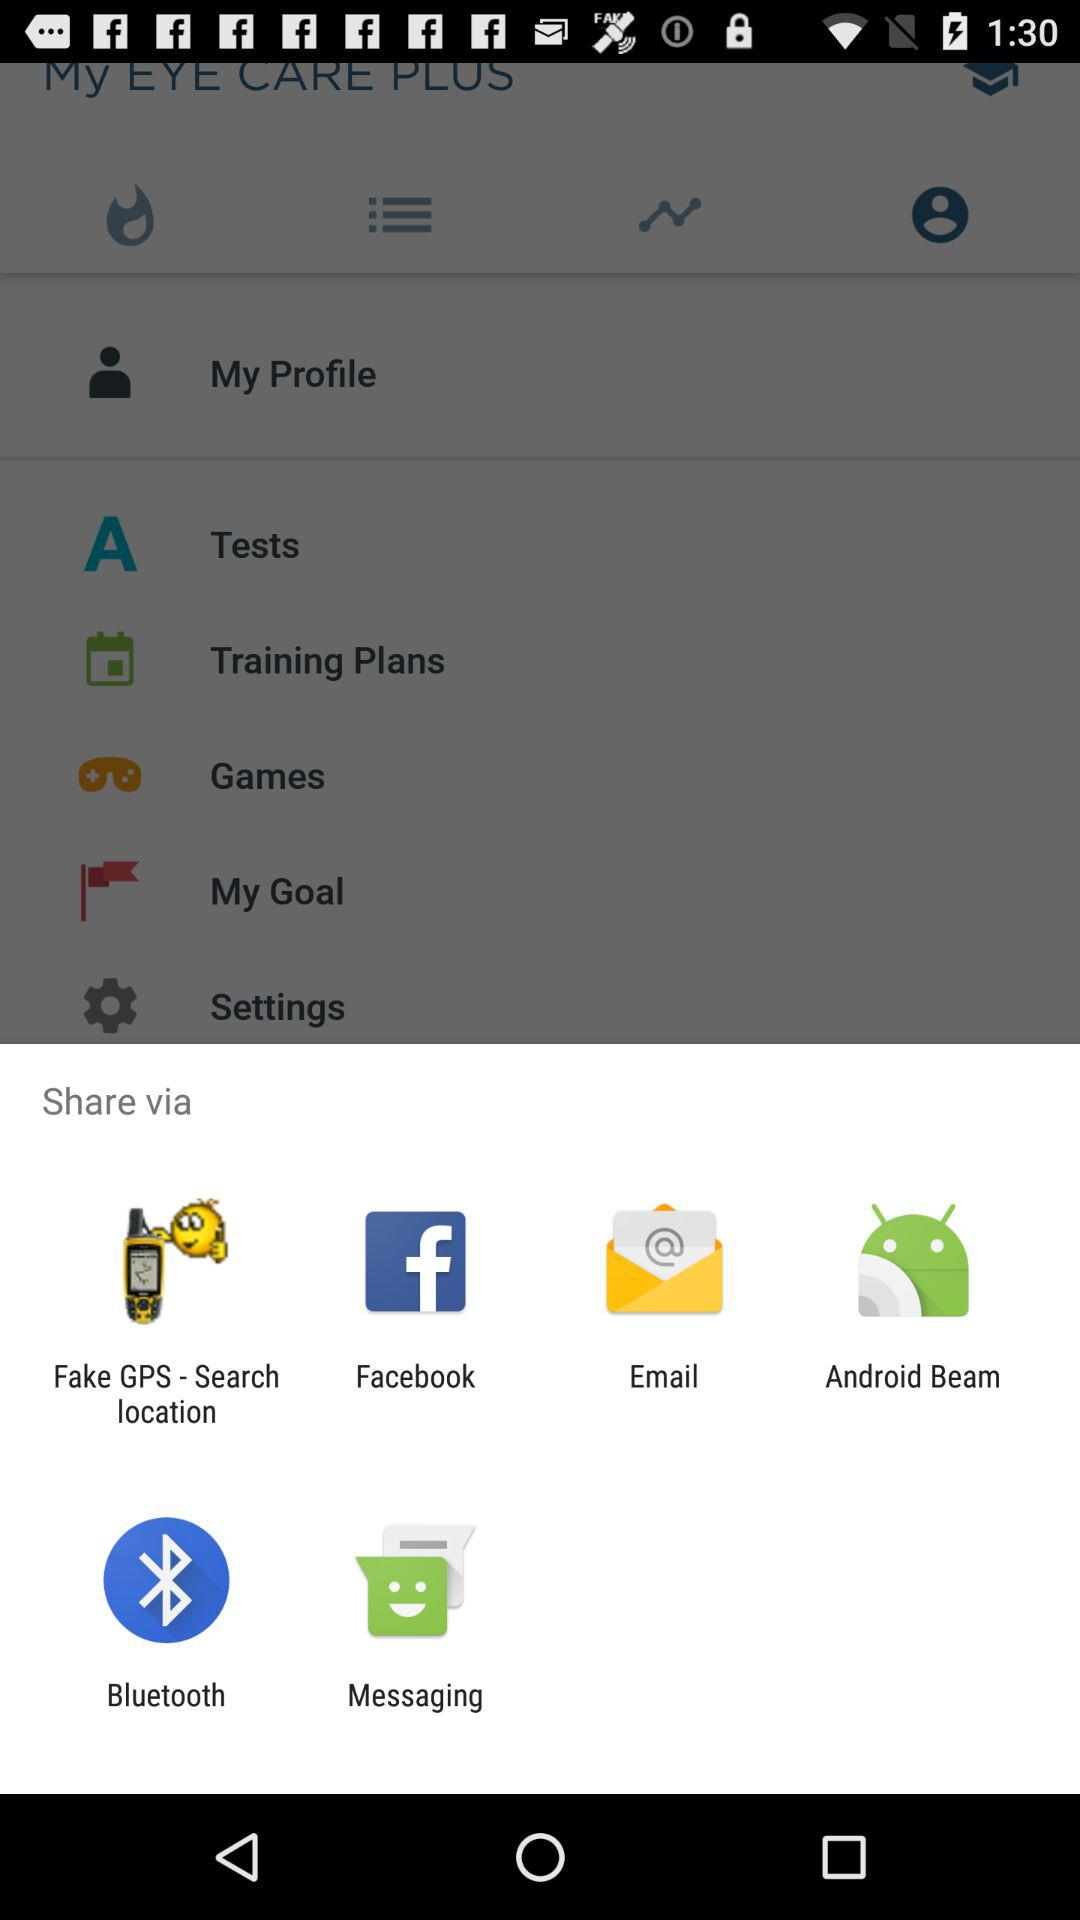What are the different mediums to share? The different mediums are "Fake GPS - Search location", "Facebook", "Email", "Android Beam", "Bluetooth" and "Messaging". 